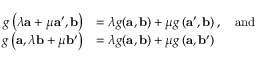Convert formula to latex. <formula><loc_0><loc_0><loc_500><loc_500>{ \begin{array} { r l } { g \left ( \lambda a + \mu a ^ { \prime } , b \right ) } & { = \lambda g ( a , b ) + \mu g \left ( a ^ { \prime } , b \right ) , \quad a n d } \\ { g \left ( a , \lambda b + \mu b ^ { \prime } \right ) } & { = \lambda g ( a , b ) + \mu g \left ( a , b ^ { \prime } \right ) } \end{array} }</formula> 